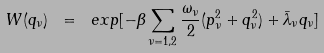Convert formula to latex. <formula><loc_0><loc_0><loc_500><loc_500>W ( q _ { \nu } ) \ = \ e x p [ - \beta \sum _ { \nu = 1 , 2 } \frac { \omega _ { \nu } } { 2 } ( p _ { \nu } ^ { 2 } + q _ { \nu } ^ { 2 } ) + \bar { \lambda } _ { \nu } q _ { \nu } ]</formula> 